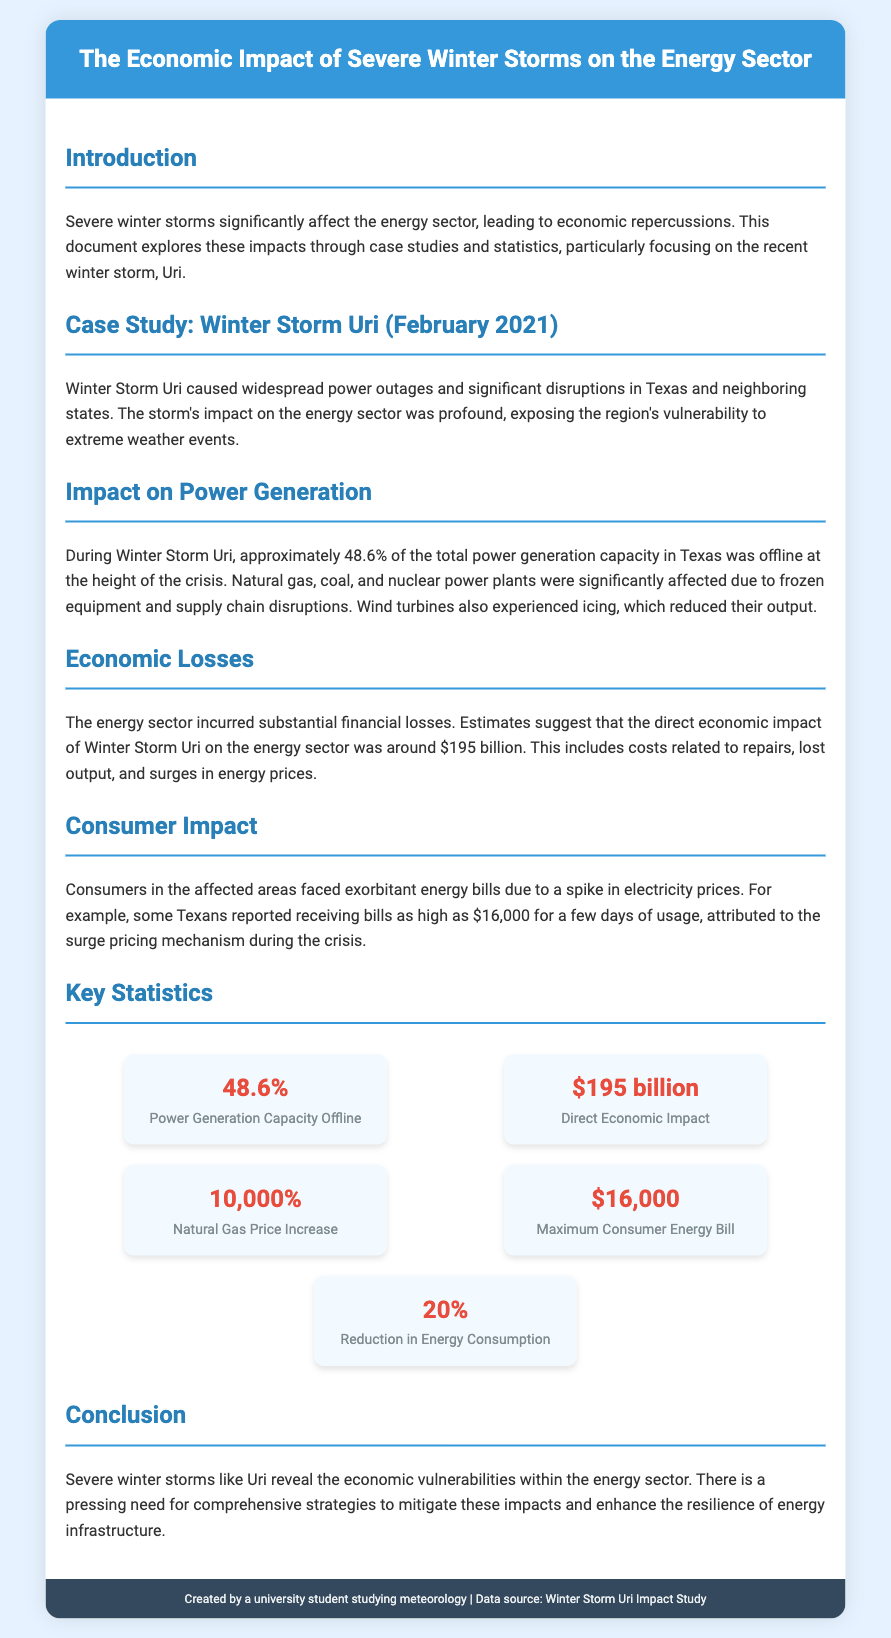What was the impact on Texas power generation during Winter Storm Uri? Approximately 48.6% of the total power generation capacity in Texas was offline, indicating a significant disruption in energy availability.
Answer: 48.6% What were the estimated direct economic impacts of Winter Storm Uri? The document states that the direct economic impact on the energy sector was about $195 billion, reflecting substantial financial losses.
Answer: $195 billion What was the maximum consumer energy bill reported during the storm? Some Texans faced extremely high bills, with reports citing a maximum of $16,000 for only a few days of usage.
Answer: $16,000 How much did natural gas prices increase during Winter Storm Uri? The document mentions a staggering increase in natural gas prices, with some reports indicating a rise of 10,000%.
Answer: 10,000% What is the percentage reduction in energy consumption mentioned? The text notes a reduction in energy consumption during the storm, indicating a broader impact on consumer activity and usage patterns.
Answer: 20% What type of document is this? The content is structured as a ballot discussing economic impacts, featuring case studies and statistics on energy sector vulnerabilities during severe winter storms.
Answer: Ballot What was the background color of the document? The background color of the document is designed to create an appealing layout, specifically noted as #e6f2ff in the styling.
Answer: #e6f2ff Which storm's impact is primarily discussed in the document? The focus is specifically on the case study of Winter Storm Uri that occurred in February 2021, highlighting its effects on the energy sector.
Answer: Winter Storm Uri 